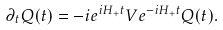Convert formula to latex. <formula><loc_0><loc_0><loc_500><loc_500>\partial _ { t } Q ( t ) = - i e ^ { i H _ { + } t } V e ^ { - i H _ { + } t } Q ( t ) .</formula> 